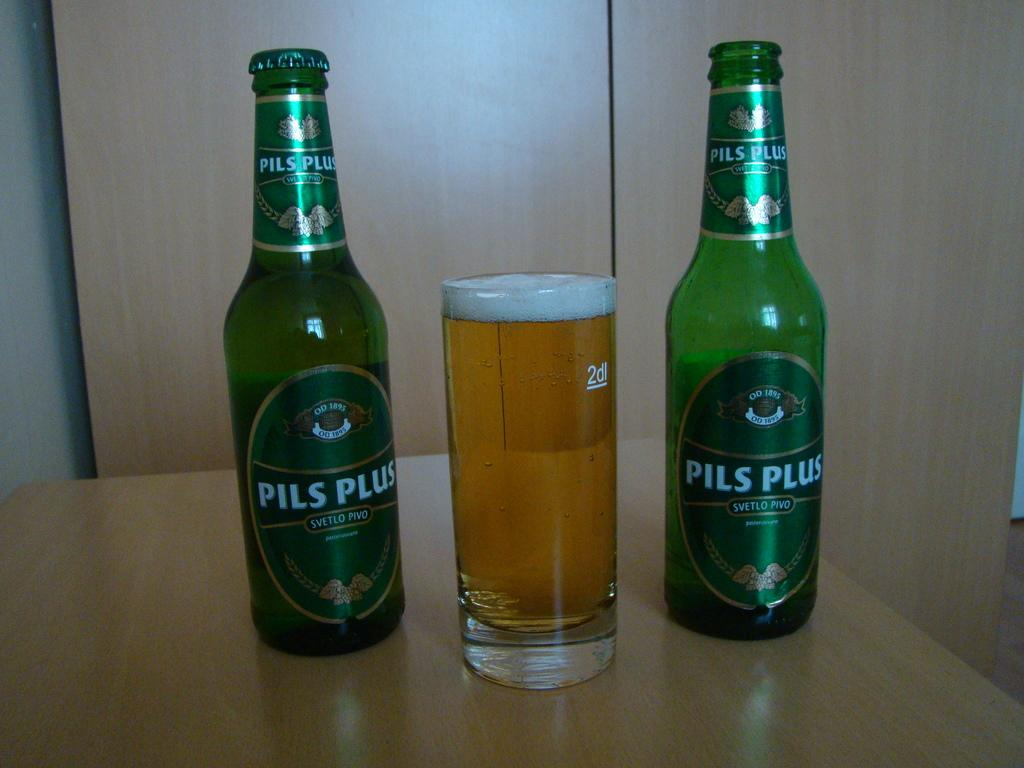<image>
Write a terse but informative summary of the picture. Two bottle of Pils Plus have a filled glass between them. 